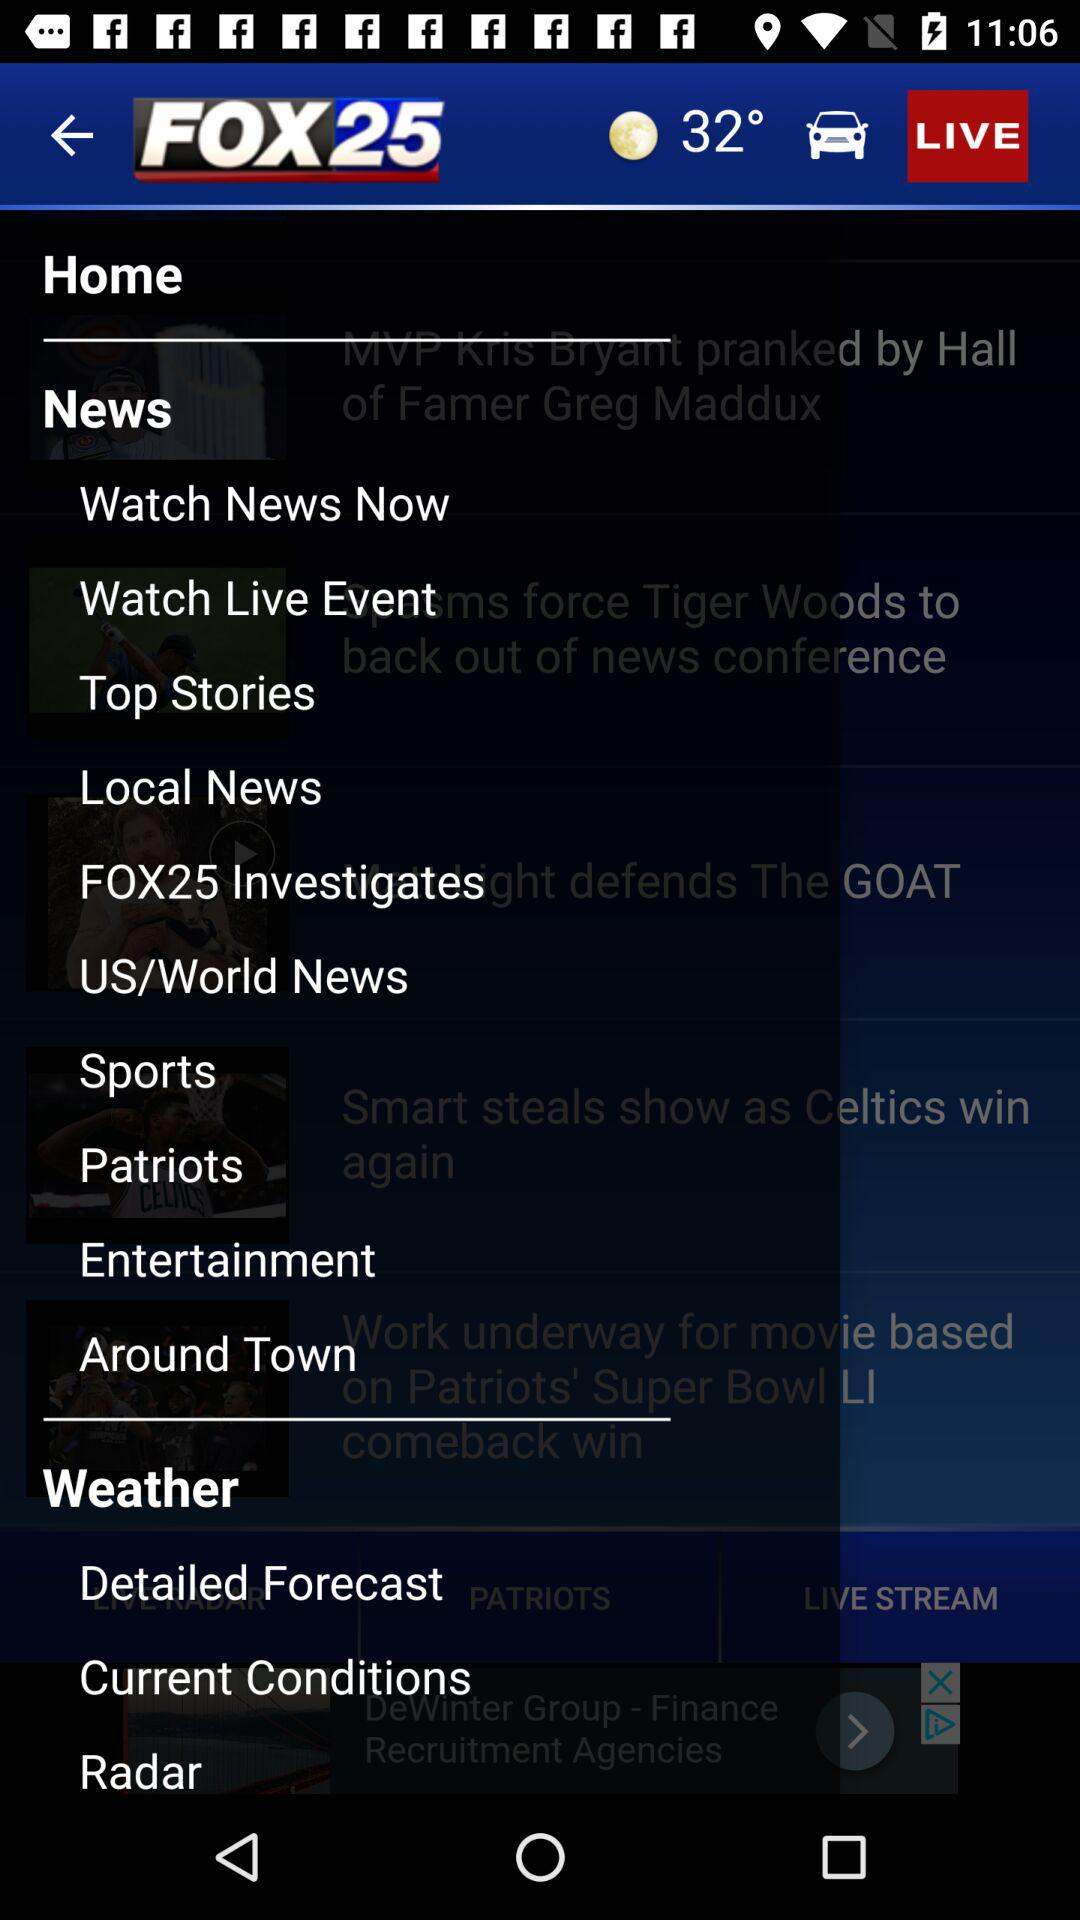How many notifications are there in "Radar"?
When the provided information is insufficient, respond with <no answer>. <no answer> 